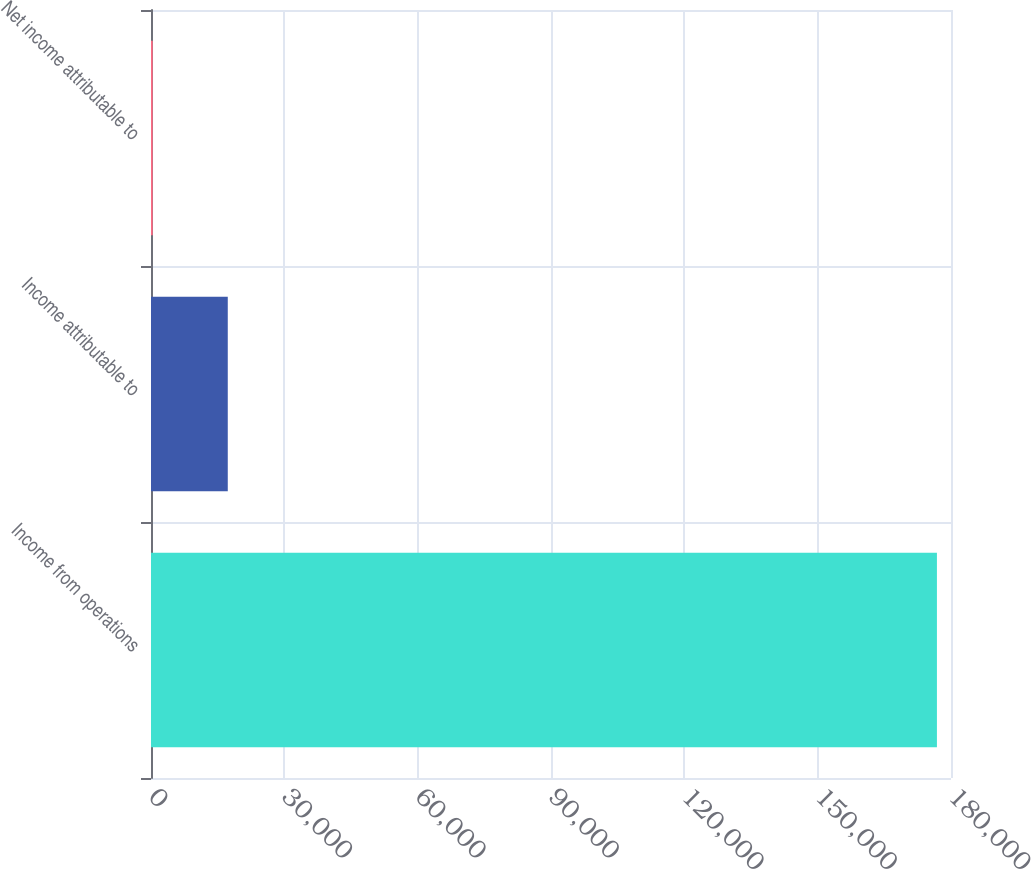Convert chart. <chart><loc_0><loc_0><loc_500><loc_500><bar_chart><fcel>Income from operations<fcel>Income attributable to<fcel>Net income attributable to<nl><fcel>176834<fcel>17273.5<fcel>388<nl></chart> 